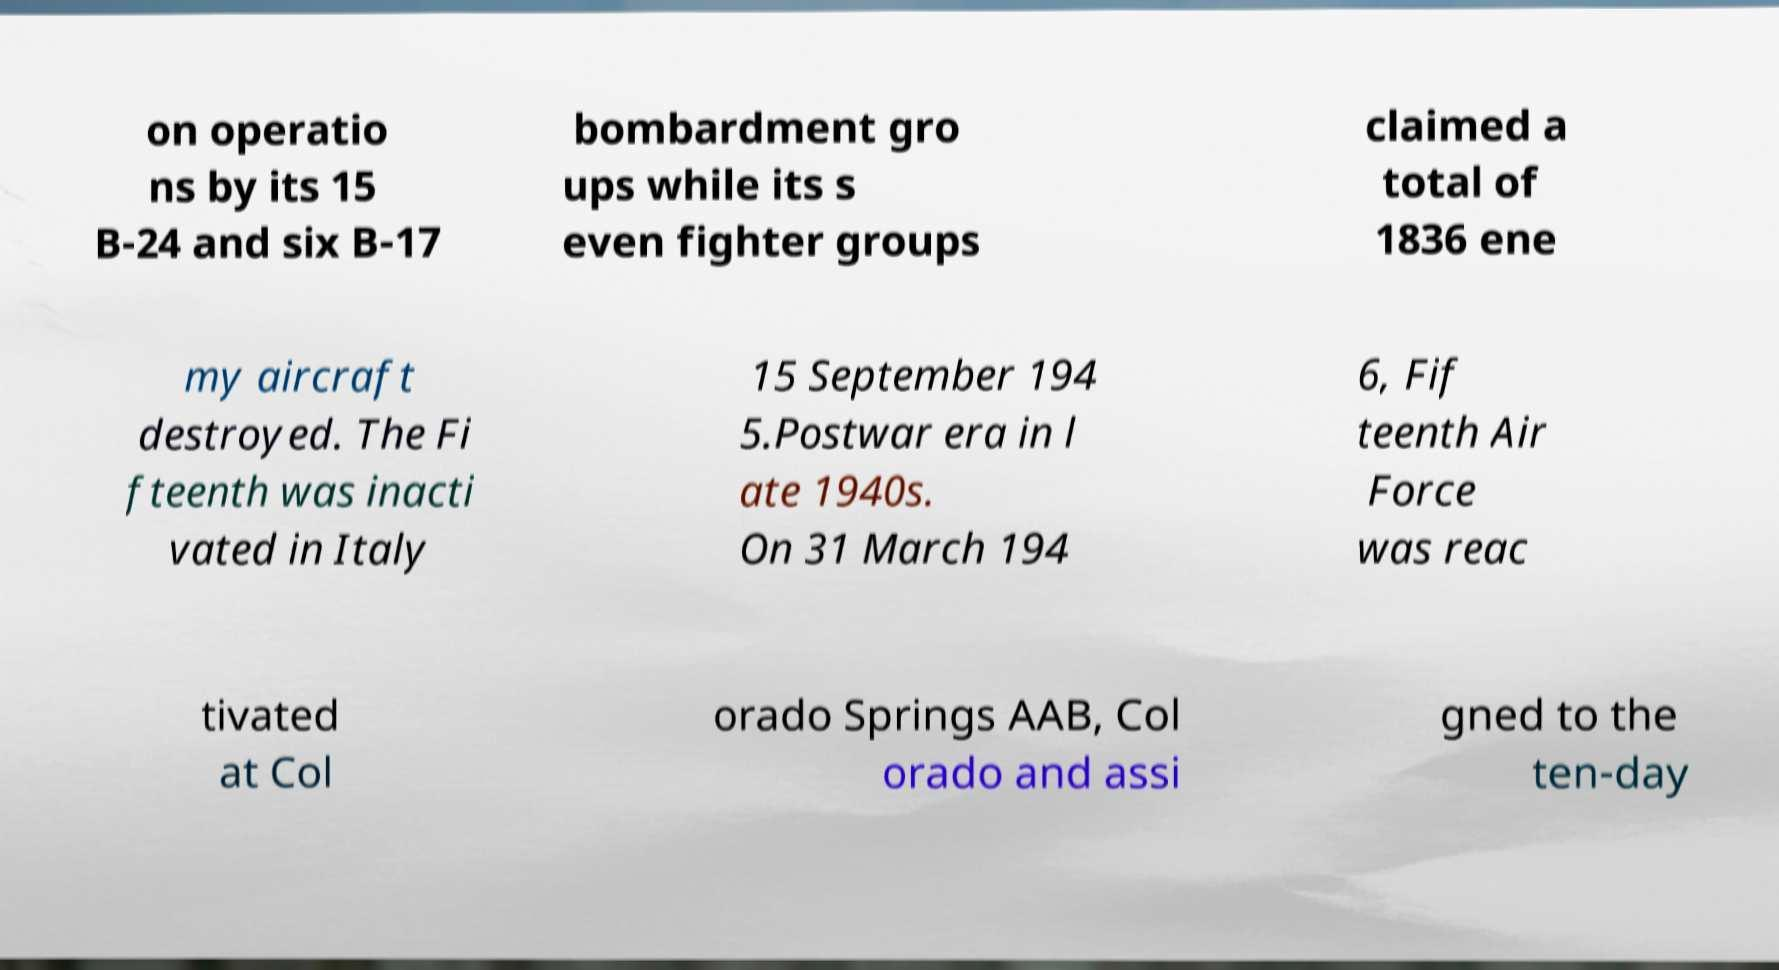I need the written content from this picture converted into text. Can you do that? on operatio ns by its 15 B-24 and six B-17 bombardment gro ups while its s even fighter groups claimed a total of 1836 ene my aircraft destroyed. The Fi fteenth was inacti vated in Italy 15 September 194 5.Postwar era in l ate 1940s. On 31 March 194 6, Fif teenth Air Force was reac tivated at Col orado Springs AAB, Col orado and assi gned to the ten-day 